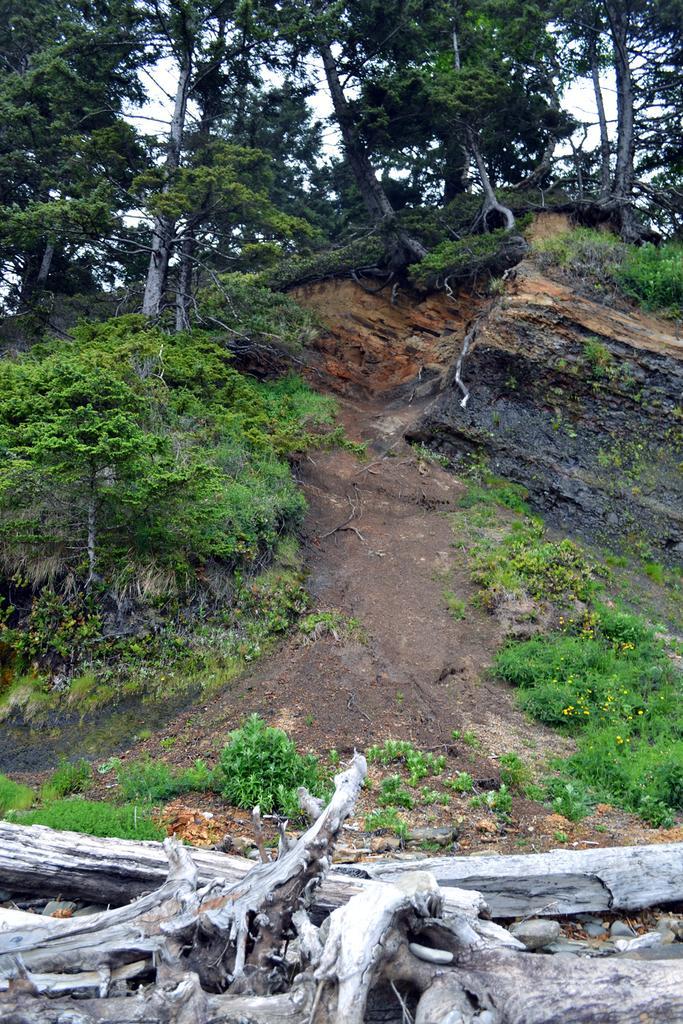Could you give a brief overview of what you see in this image? In this image we can see many trees and plants. There are many flowers to the plants. We can see the sky in the image. There is a wooden object at the bottom of the image. 